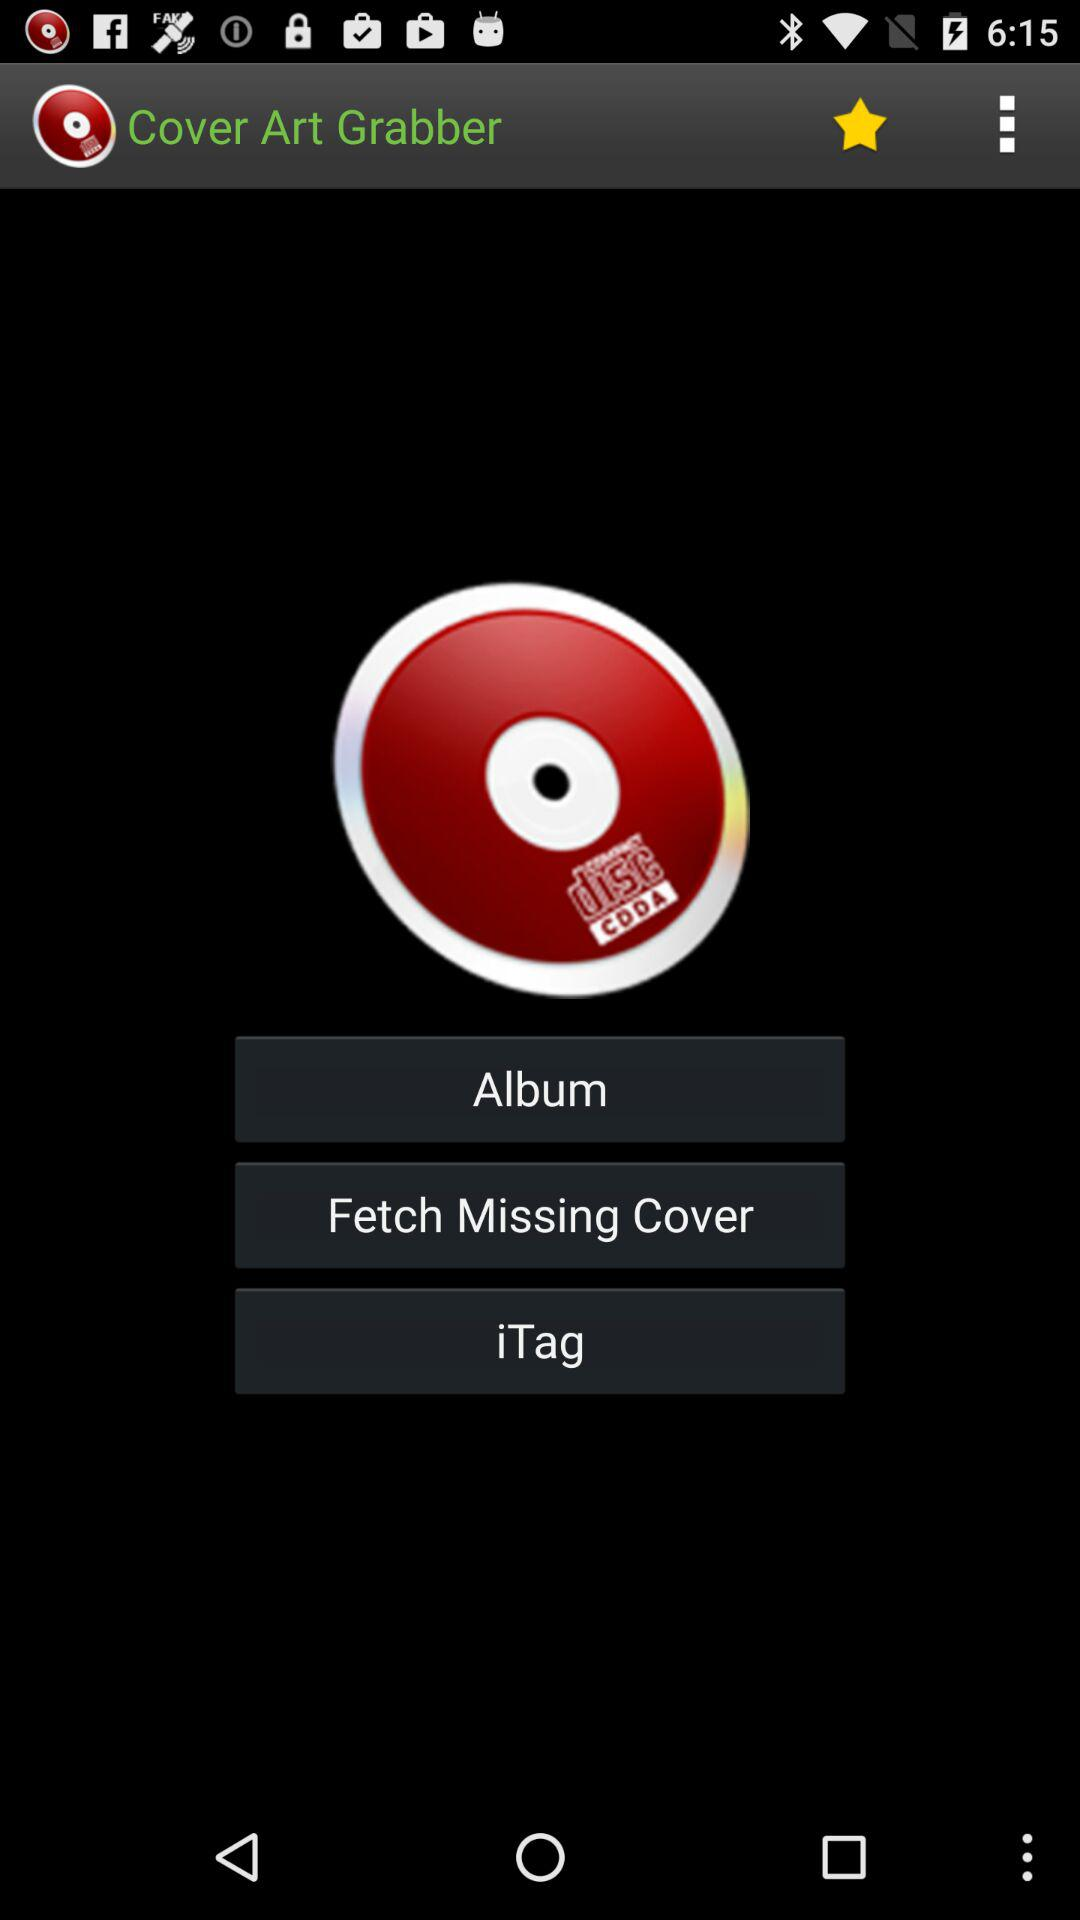Which album's cover art is selected?
When the provided information is insufficient, respond with <no answer>. <no answer> 